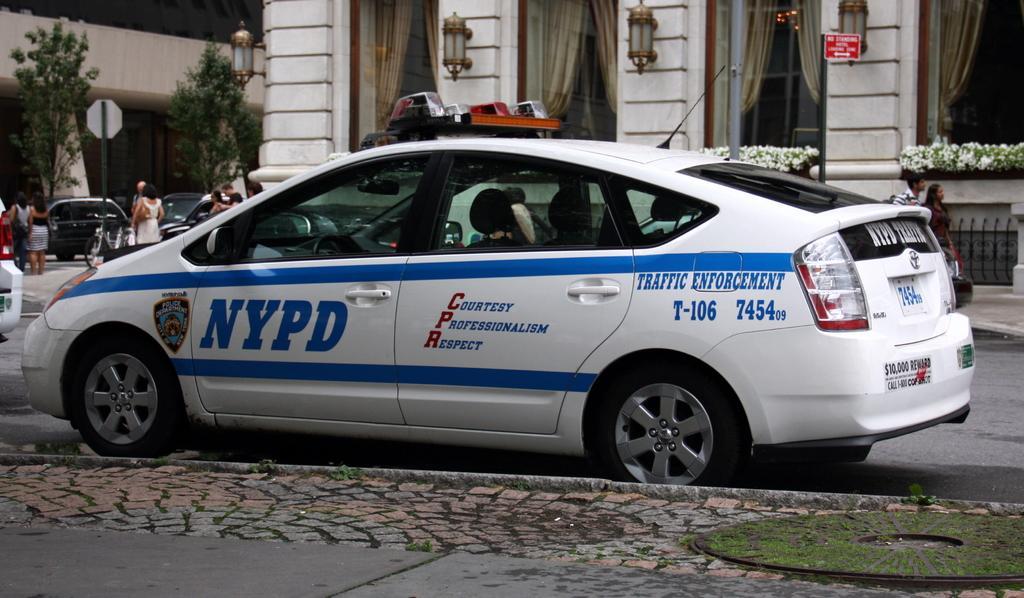How would you summarize this image in a sentence or two? This image consists of a car in white color. At the bottom, there is a pavement. The car is on the road. In the background, there is a building along with the lights. To the left, there are many people on the road. 